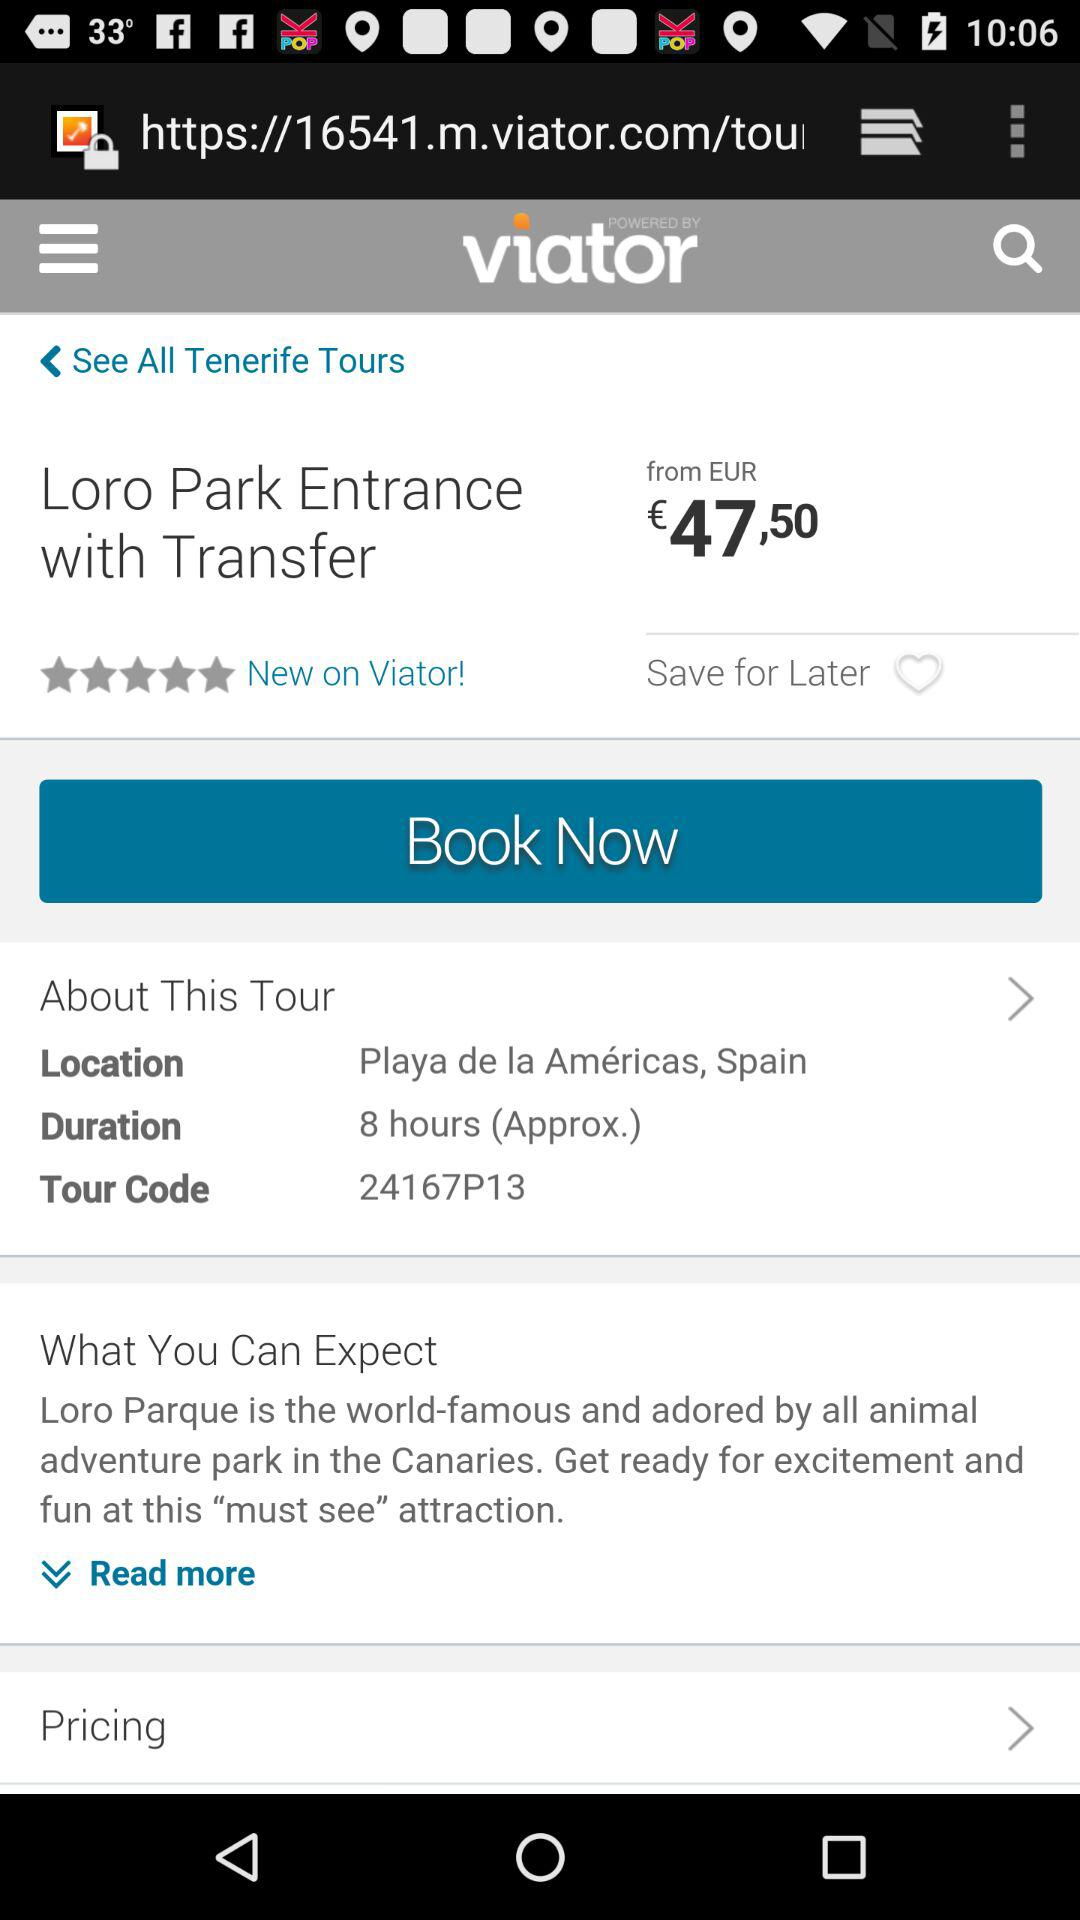What is the duration of the "Loro Park" tour? The duration of the tour is approximately 8 hours. 